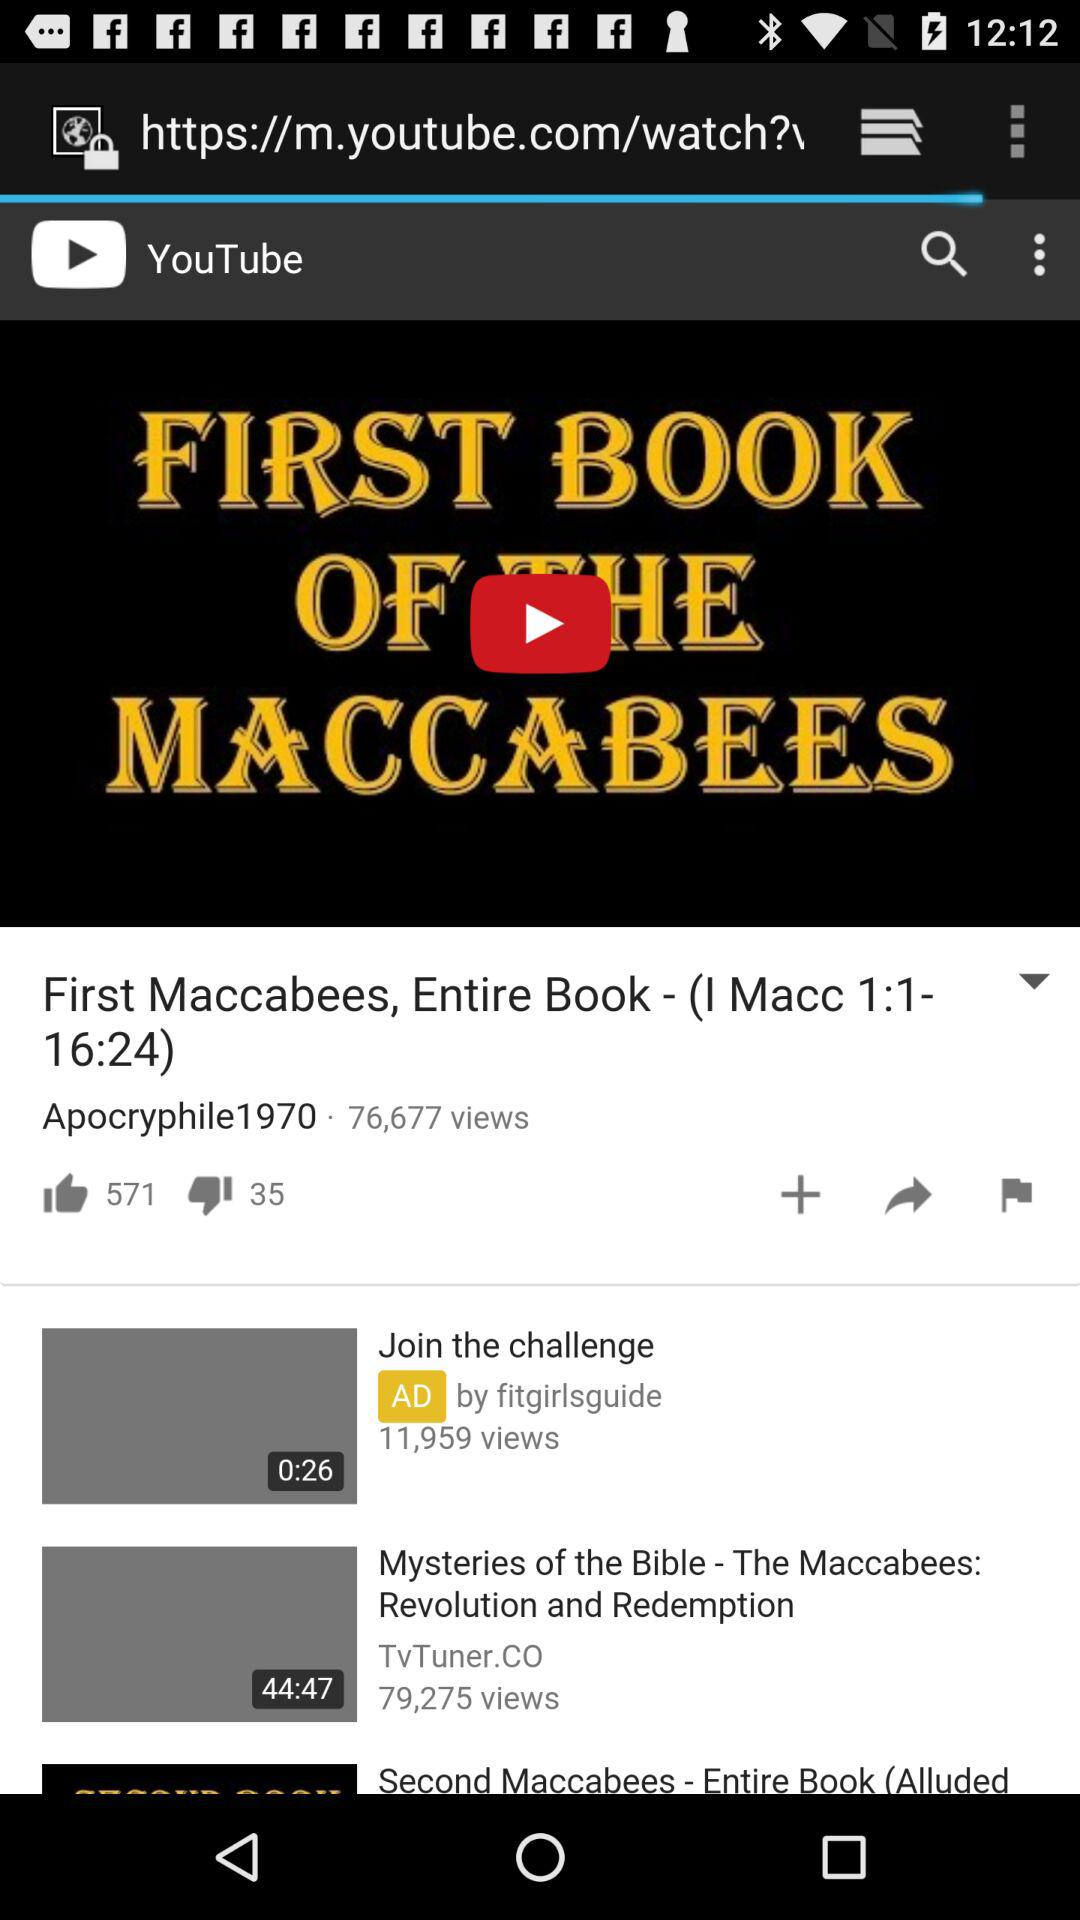What is the number of views of the video "First Maccabees, Entire Book - (I Macc 1:1-16:24)"? The number of views is 76,677. 